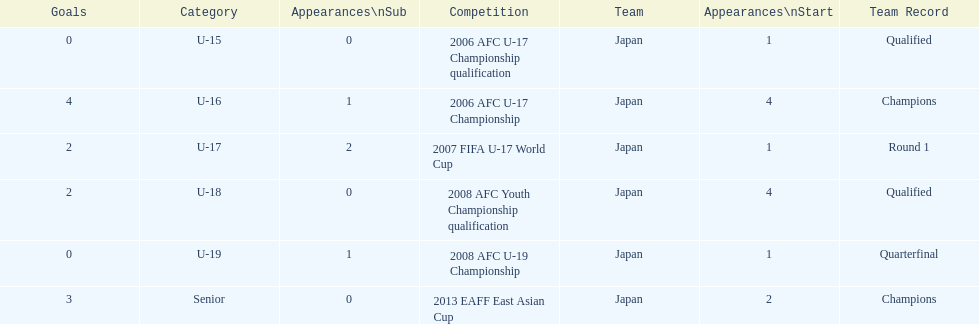Would you be able to parse every entry in this table? {'header': ['Goals', 'Category', 'Appearances\\nSub', 'Competition', 'Team', 'Appearances\\nStart', 'Team Record'], 'rows': [['0', 'U-15', '0', '2006 AFC U-17 Championship qualification', 'Japan', '1', 'Qualified'], ['4', 'U-16', '1', '2006 AFC U-17 Championship', 'Japan', '4', 'Champions'], ['2', 'U-17', '2', '2007 FIFA U-17 World Cup', 'Japan', '1', 'Round 1'], ['2', 'U-18', '0', '2008 AFC Youth Championship qualification', 'Japan', '4', 'Qualified'], ['0', 'U-19', '1', '2008 AFC U-19 Championship', 'Japan', '1', 'Quarterfinal'], ['3', 'Senior', '0', '2013 EAFF East Asian Cup', 'Japan', '2', 'Champions']]} Yoichiro kakitani scored above 2 goals in how many major competitions? 2. 